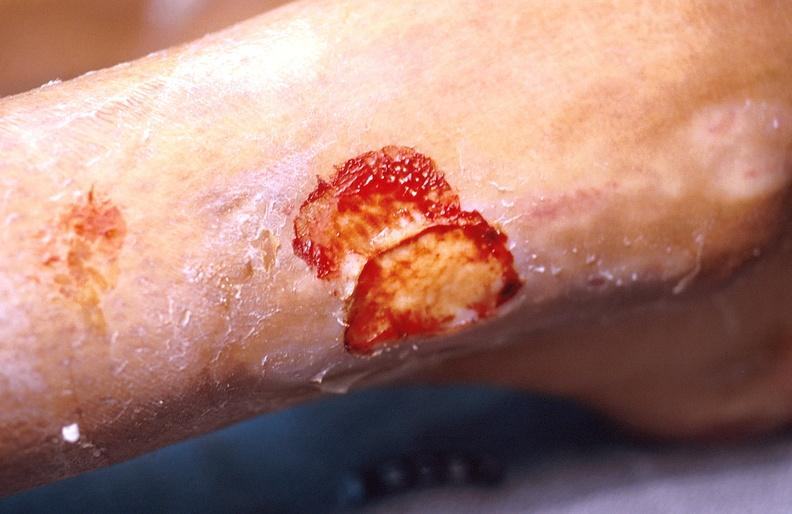does foot show cellulitis?
Answer the question using a single word or phrase. No 